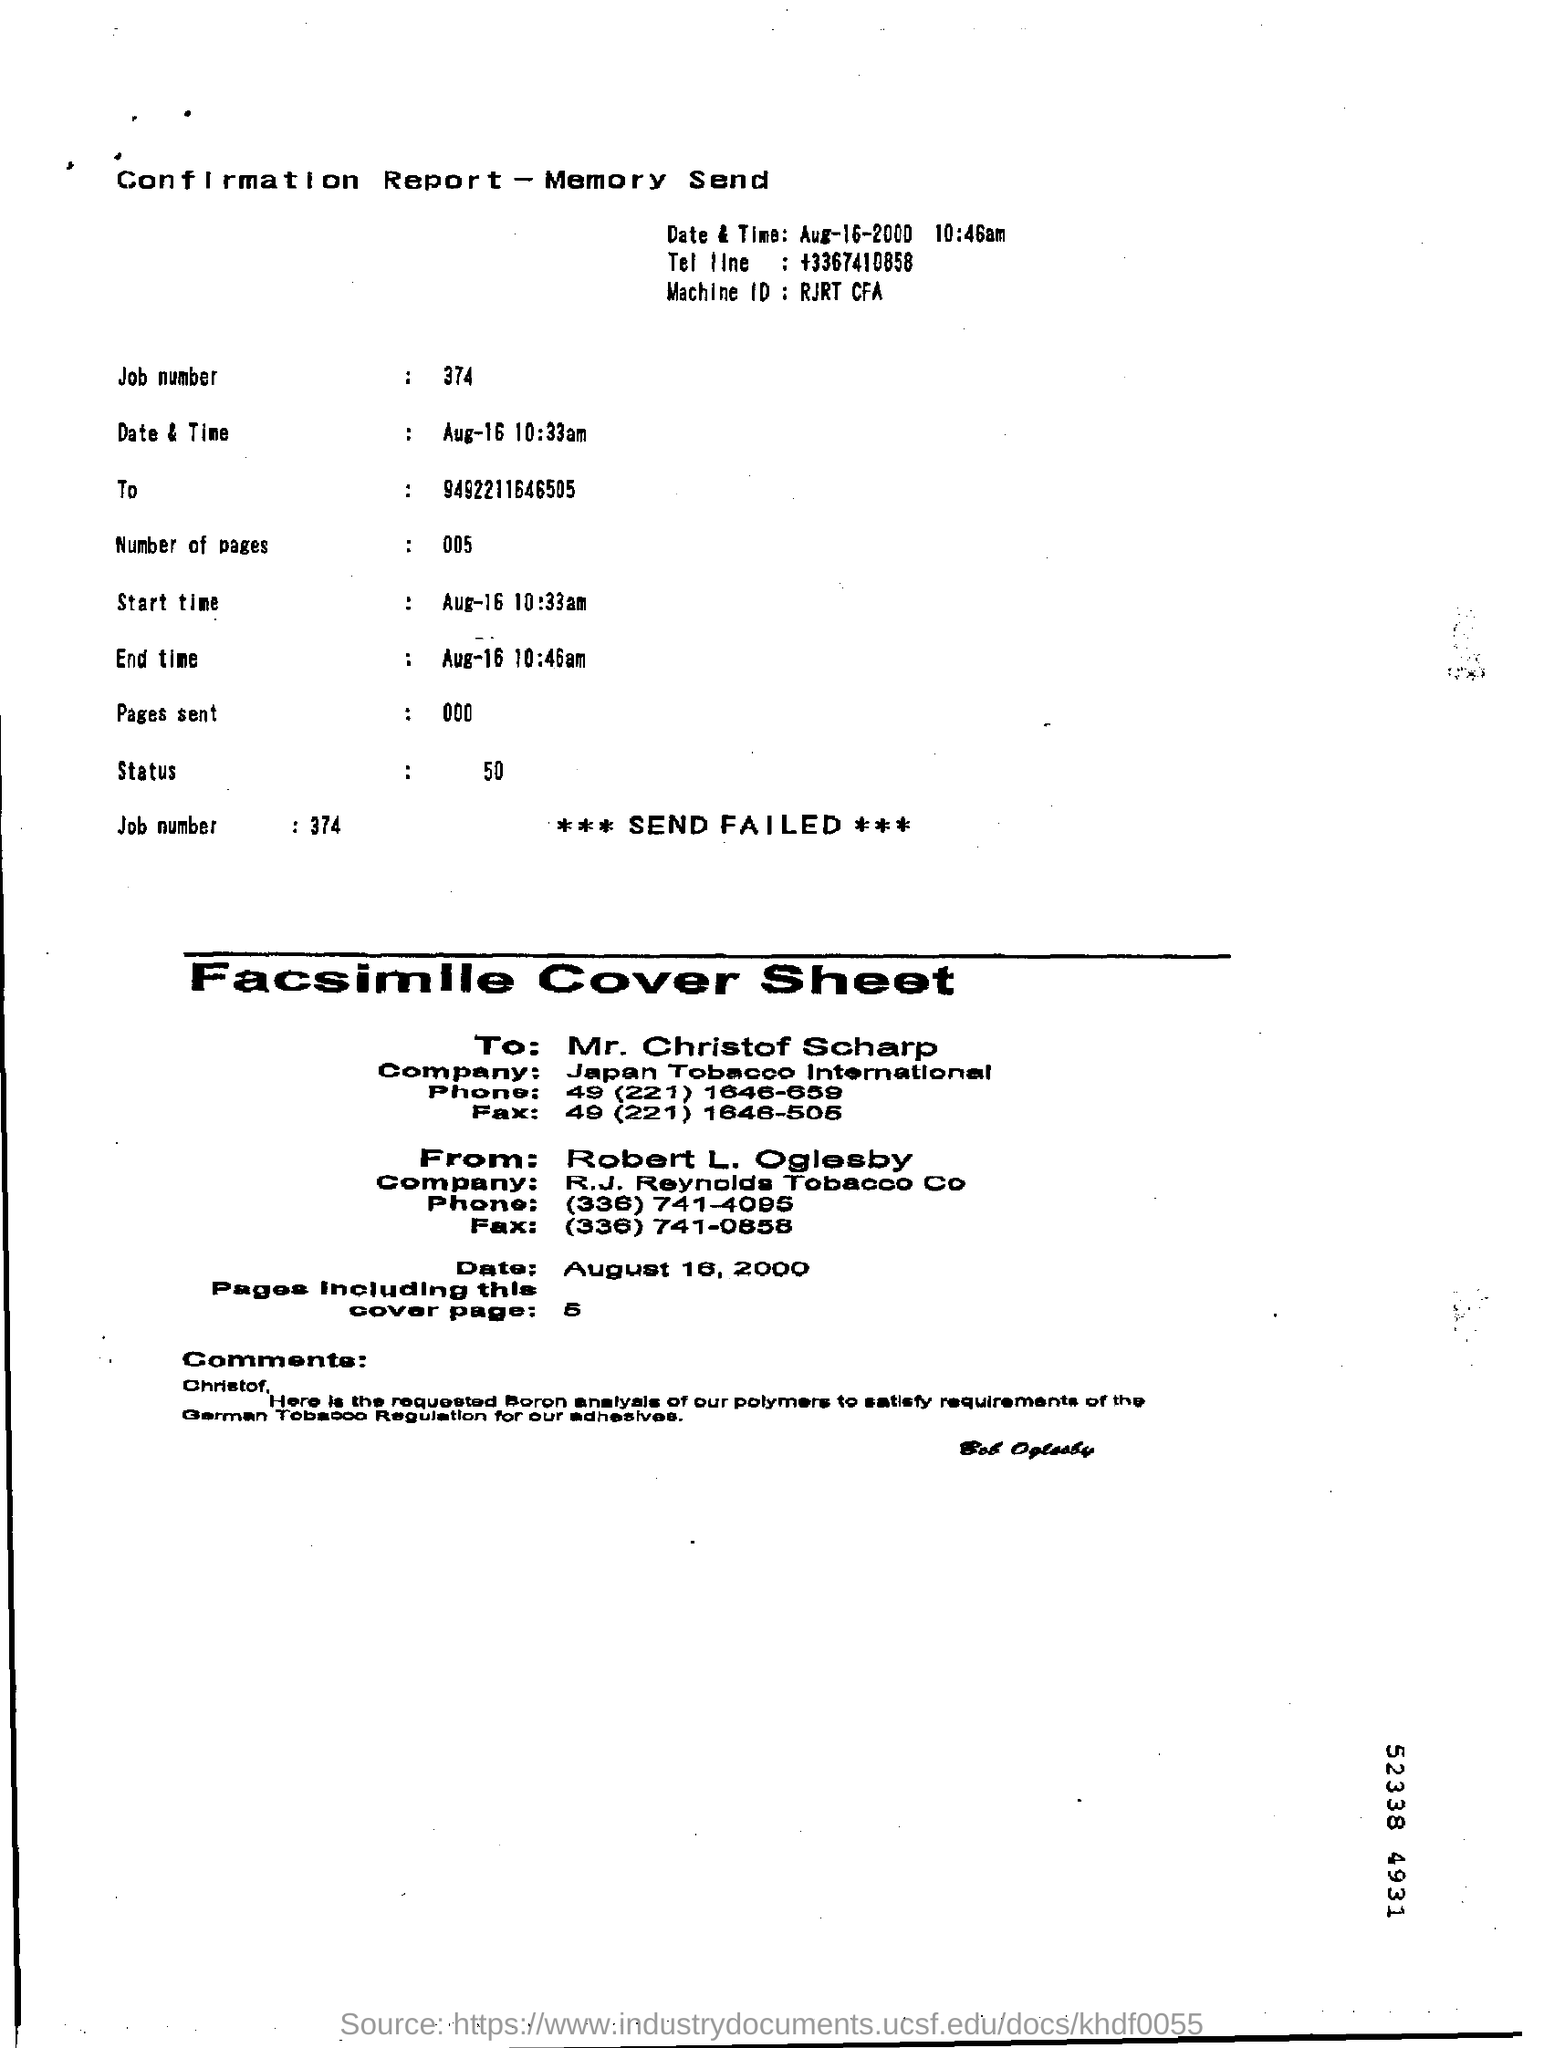Point out several critical features in this image. The phone number of Mr. Christof Scharp is 49 (221) 1646-659... The company name of Mr. Christof Scharp is Japan Tobacco International. The job number is 374. Robert L. Oglesby is the sender of the facsimile cover sheet. 